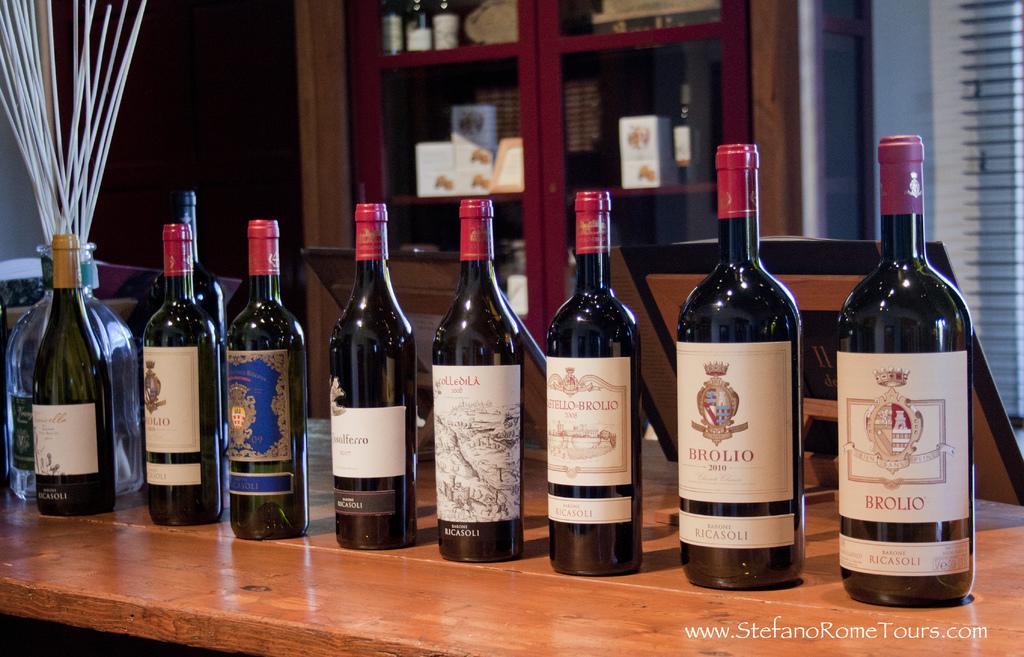What is the vintage of the bottle second from the right?
Offer a very short reply. 2010. 